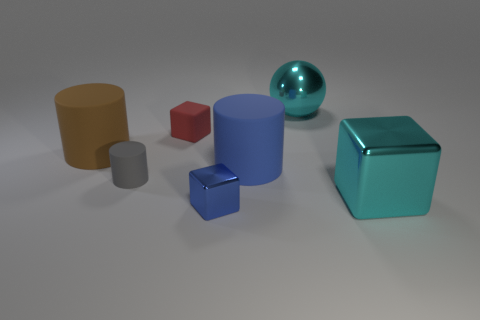Do the large sphere and the big block have the same color?
Offer a terse response. Yes. Are there an equal number of cyan things behind the small gray rubber thing and cyan cubes?
Keep it short and to the point. Yes. How many other big metallic things have the same shape as the big brown object?
Provide a short and direct response. 0. Is the tiny red rubber thing the same shape as the small blue thing?
Provide a short and direct response. Yes. How many things are rubber cylinders to the left of the tiny gray rubber cylinder or shiny cubes?
Provide a short and direct response. 3. The tiny rubber thing that is behind the matte thing that is right of the metal thing that is on the left side of the large cyan metal ball is what shape?
Provide a short and direct response. Cube. There is a small blue object that is the same material as the ball; what is its shape?
Make the answer very short. Cube. The rubber cube is what size?
Make the answer very short. Small. Do the gray rubber cylinder and the blue matte cylinder have the same size?
Keep it short and to the point. No. What number of things are cubes that are to the left of the big sphere or big cyan metal objects that are in front of the large shiny ball?
Offer a terse response. 3. 